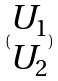<formula> <loc_0><loc_0><loc_500><loc_500>( \begin{matrix} U _ { 1 } \\ U _ { 2 } \end{matrix} )</formula> 